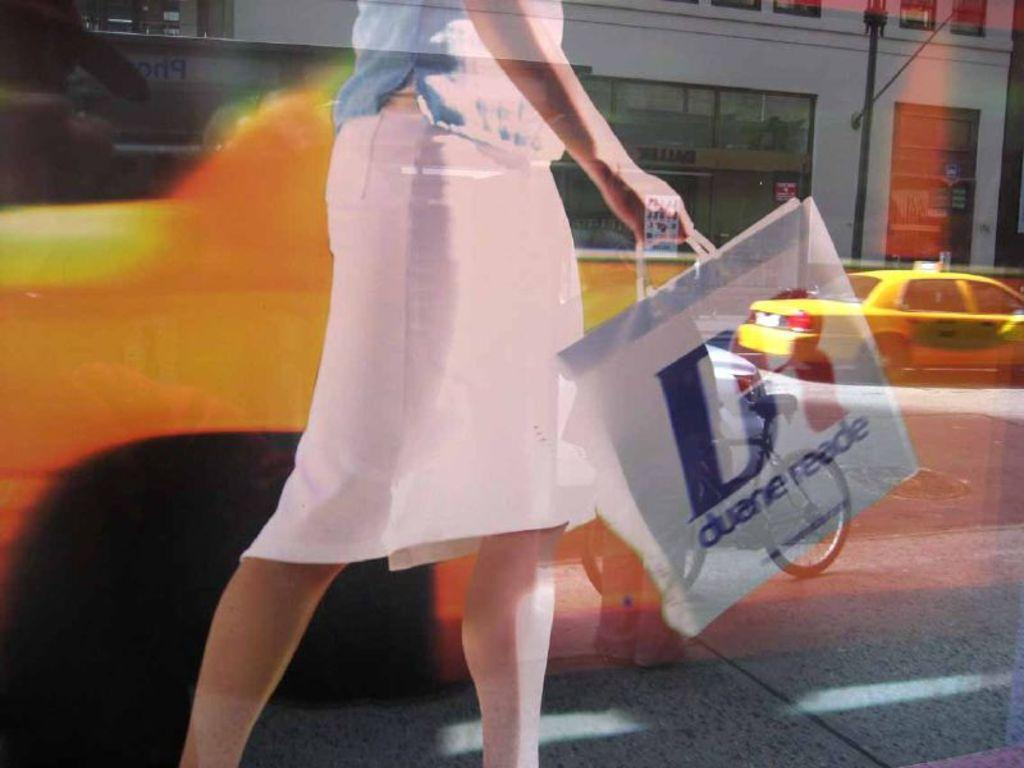<image>
Provide a brief description of the given image. A woman in a pink dress carrying a Duane Reade bag. 